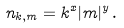Convert formula to latex. <formula><loc_0><loc_0><loc_500><loc_500>n _ { { k } , m } = k ^ { x } | m | ^ { y } \, .</formula> 